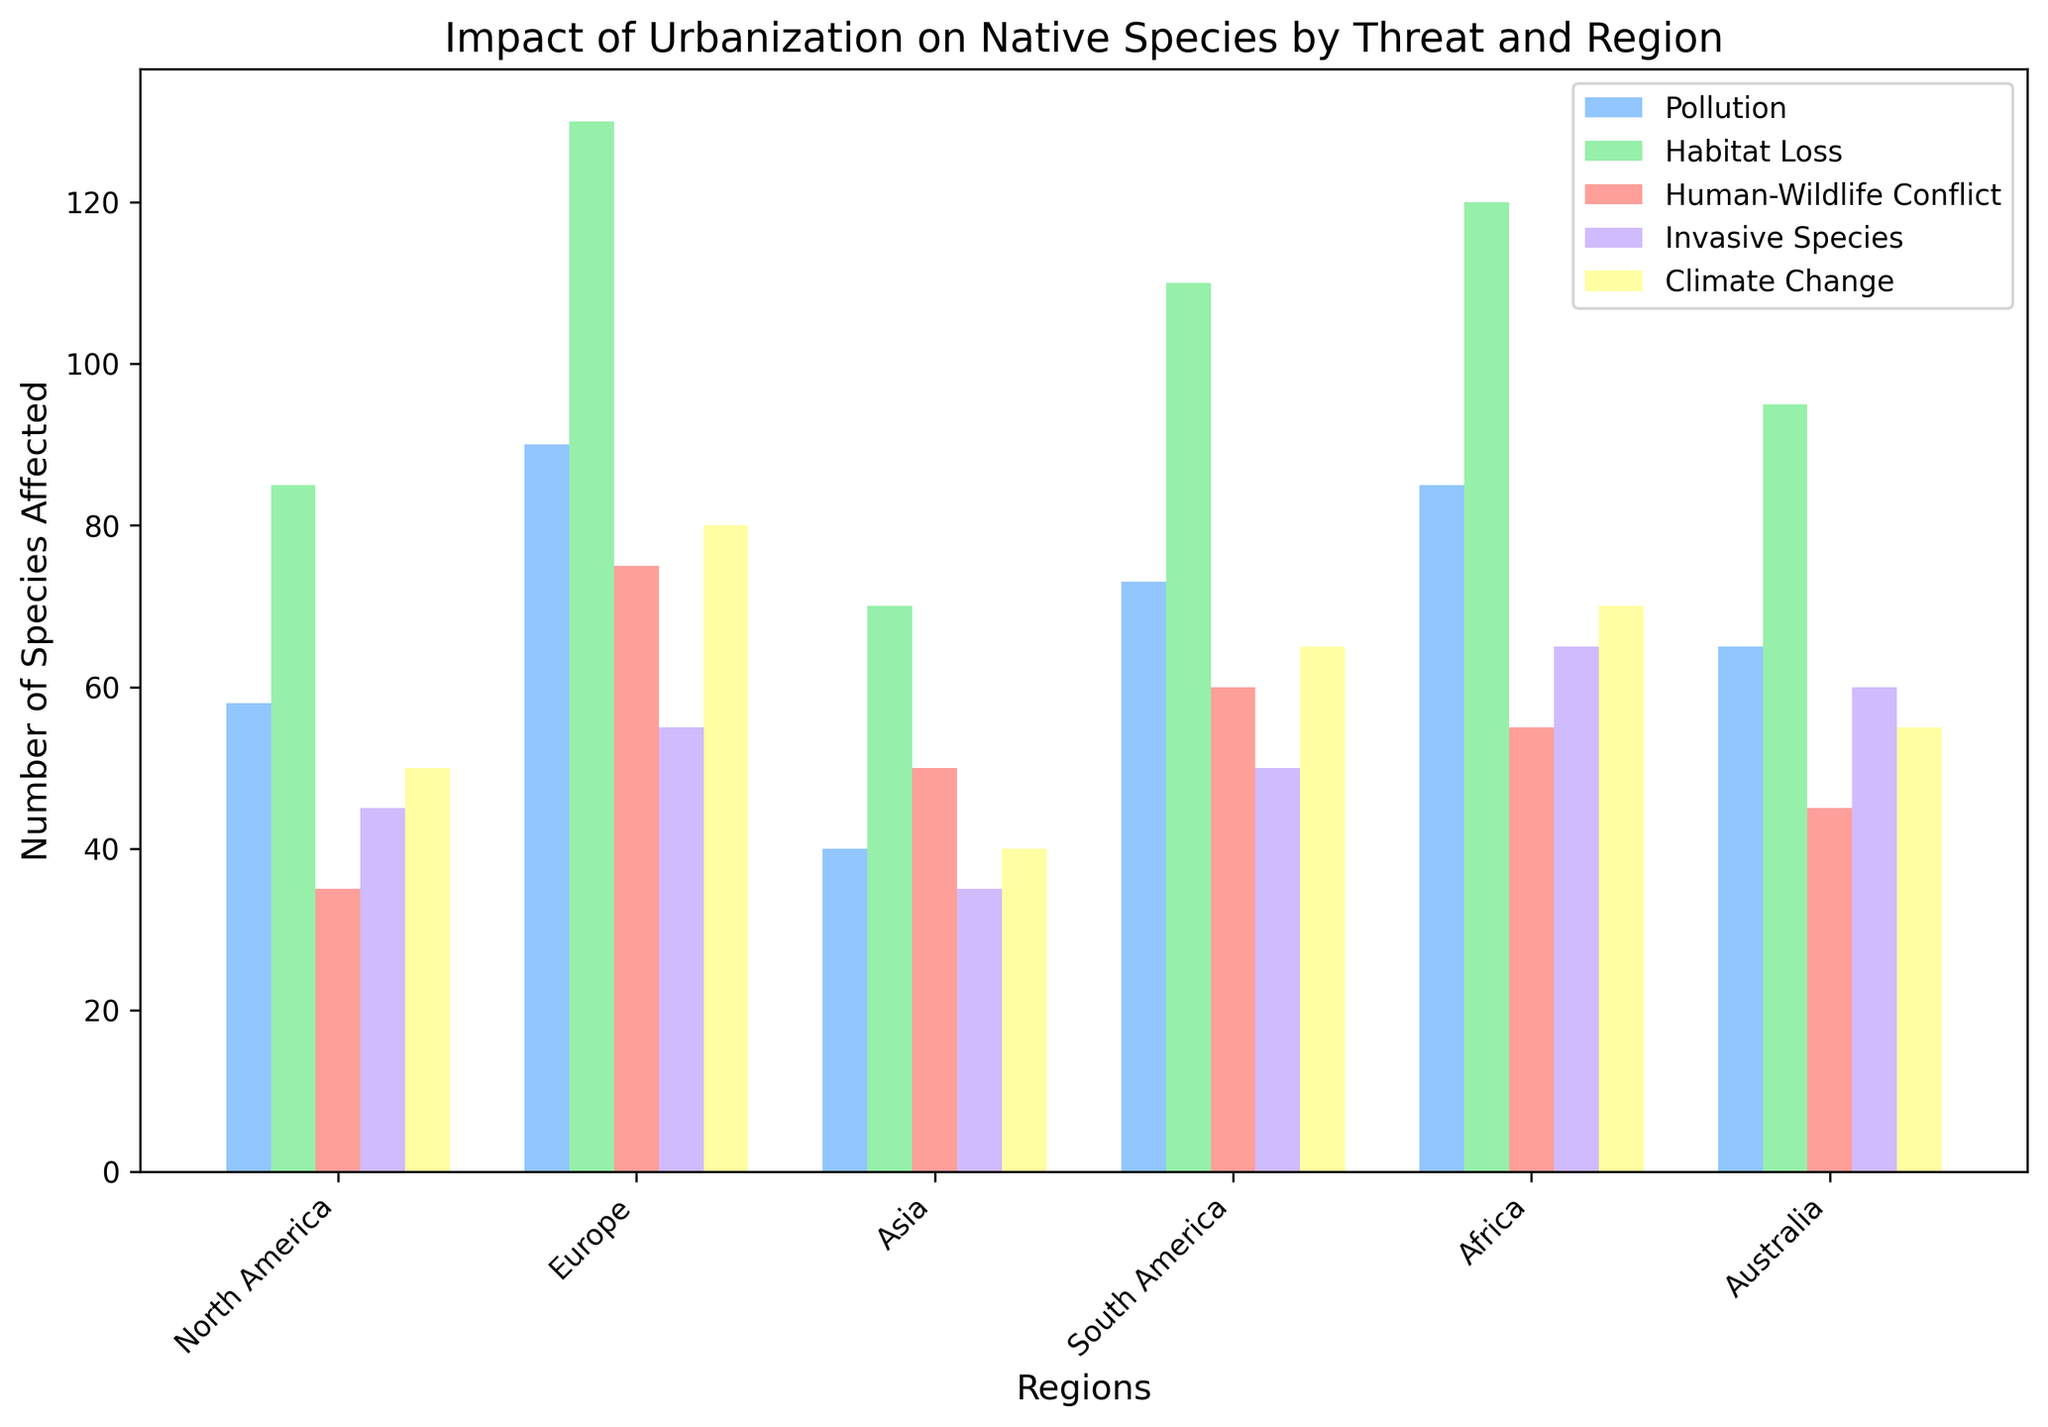Which region shows the highest number of species affected by pollution? Look at the bar corresponding to pollution in each region and identify the tallest bar. The tallest bar for pollution is in Asia.
Answer: Asia How many more species are affected by habitat loss than by human-wildlife conflict in North America? Locate the bars for habitat loss and human-wildlife conflict in North America. The bar for habitat loss indicates 120 species, and the bar for human-wildlife conflict indicates 55 species. Subtract 55 from 120.
Answer: 65 Which threat impacts the most species on average across all regions? Calculate the average number of species affected by each threat. Sum the values for each threat across all regions and divide by the number of regions (6). Compare the averages to find the highest one. For habitat loss: (120 + 110 + 130 + 95 + 85 + 70)/6 = 101.67, which is the highest.
Answer: Habitat Loss Is the number of species affected by invasive species greater in South America than in Australia? Compare the bar heights for invasive species in South America and Australia. South America's bar shows 60 species, whereas Australia's bar shows 35 species. Therefore, South America's number is greater.
Answer: Yes In which region does climate change affect more species than pollution? Identify the bars for climate change and pollution in each region and check where the bar for climate change is taller than for pollution. This occurs in South America and Africa.
Answer: South America, Africa What is the total number of species affected by habitat loss in Europe and Asia combined? Sum the values for habitat loss in Europe and Asia. For Europe, it is 110, and for Asia, it is 130. Therefore, the combined total is 110 + 130.
Answer: 240 Which threat has the least impact on native species in Africa? Look at the bars for each threat in Africa and find the shortest bar. The shortest bar represents human-wildlife conflict, which affects 35 species.
Answer: Human-Wildlife Conflict How many species are affected by pollution and climate change together in North America? Add the values for pollution and climate change in North America. Pollution affects 85 species, and climate change affects 70 species. Therefore, the total is 85 + 70.
Answer: 155 Which region has the least number of species affected by human-wildlife conflict? Identify the bar for human-wildlife conflict in each region and find the shortest one. The shortest bar is in Africa, affecting 35 species.
Answer: Africa 